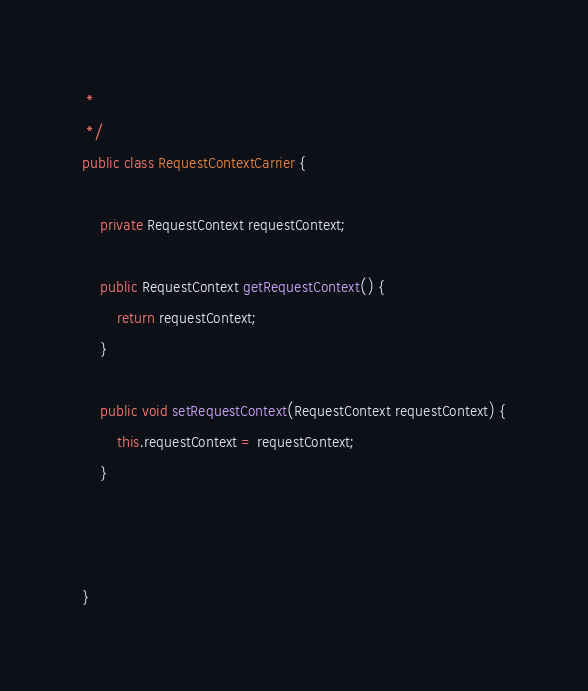<code> <loc_0><loc_0><loc_500><loc_500><_Java_> *
 */
public class RequestContextCarrier {

	private RequestContext requestContext;

	public RequestContext getRequestContext() {
		return requestContext;
	}

	public void setRequestContext(RequestContext requestContext) {
		this.requestContext = requestContext;
	}
	
	
	
}
</code> 